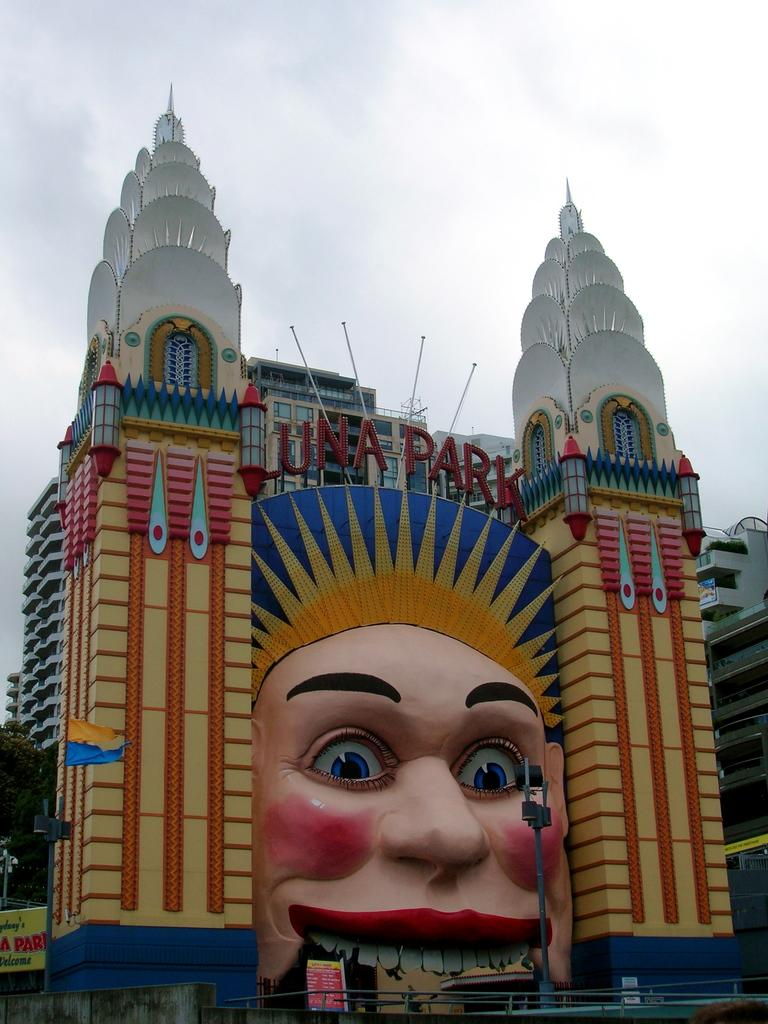What type of structures can be seen in the image? There are buildings with windows in the image. What other objects can be found in the image? There is a pole, a fence, banners, and a flag in the image. What type of vegetation is present in the image? There is a tree in the image. What can be seen in the background of the image? The sky with clouds is visible in the background of the image. What type of growth can be seen on the wall in the image? There is no wall or growth present in the image. What type of apparatus is being used by the tree in the image? There is no apparatus associated with the tree in the image. 